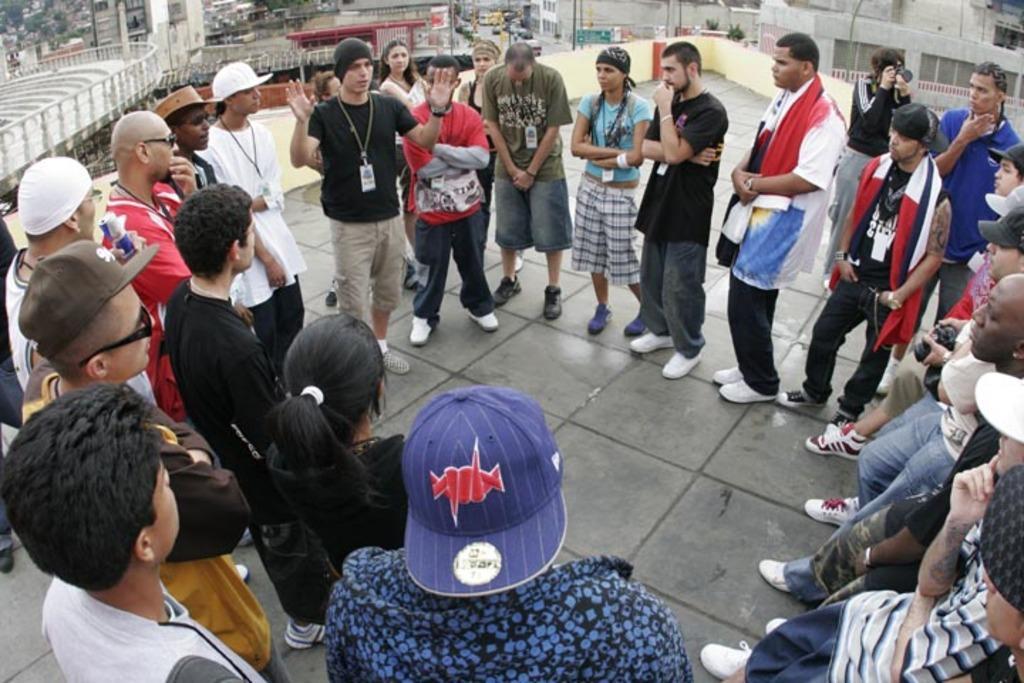How would you summarize this image in a sentence or two? In this image we can see some people standing on the floor and among them one person is talking and there are some buildings in the background. 